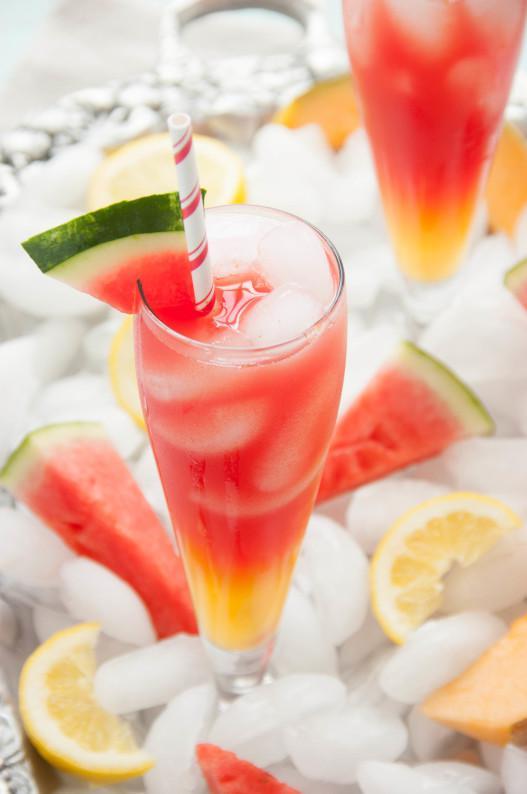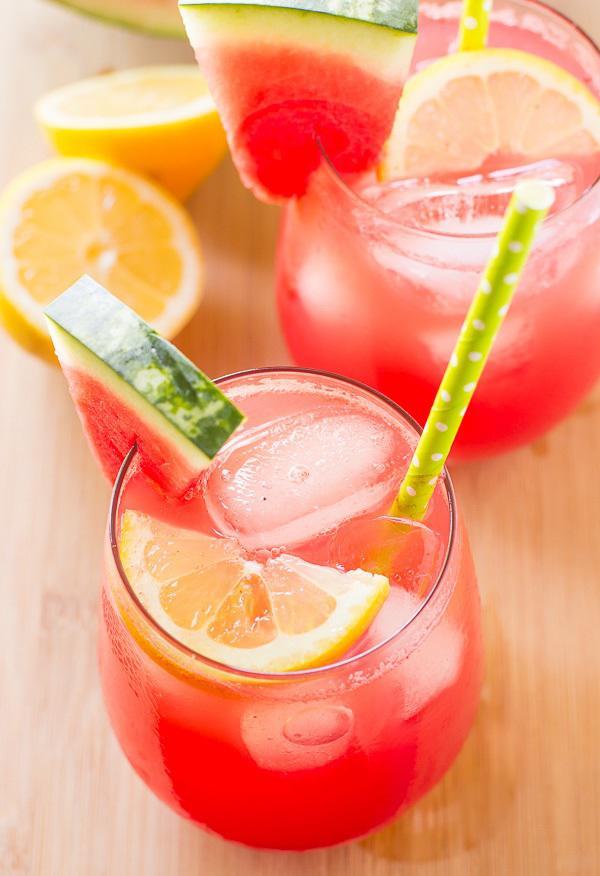The first image is the image on the left, the second image is the image on the right. Considering the images on both sides, is "Fruity drinks are garnished with fruit and striped straws." valid? Answer yes or no. Yes. The first image is the image on the left, the second image is the image on the right. Examine the images to the left and right. Is the description "All the images show drinks with straws in them." accurate? Answer yes or no. Yes. 